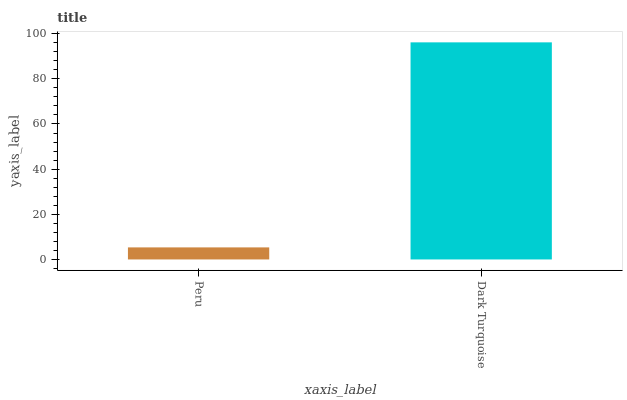Is Peru the minimum?
Answer yes or no. Yes. Is Dark Turquoise the maximum?
Answer yes or no. Yes. Is Dark Turquoise the minimum?
Answer yes or no. No. Is Dark Turquoise greater than Peru?
Answer yes or no. Yes. Is Peru less than Dark Turquoise?
Answer yes or no. Yes. Is Peru greater than Dark Turquoise?
Answer yes or no. No. Is Dark Turquoise less than Peru?
Answer yes or no. No. Is Dark Turquoise the high median?
Answer yes or no. Yes. Is Peru the low median?
Answer yes or no. Yes. Is Peru the high median?
Answer yes or no. No. Is Dark Turquoise the low median?
Answer yes or no. No. 